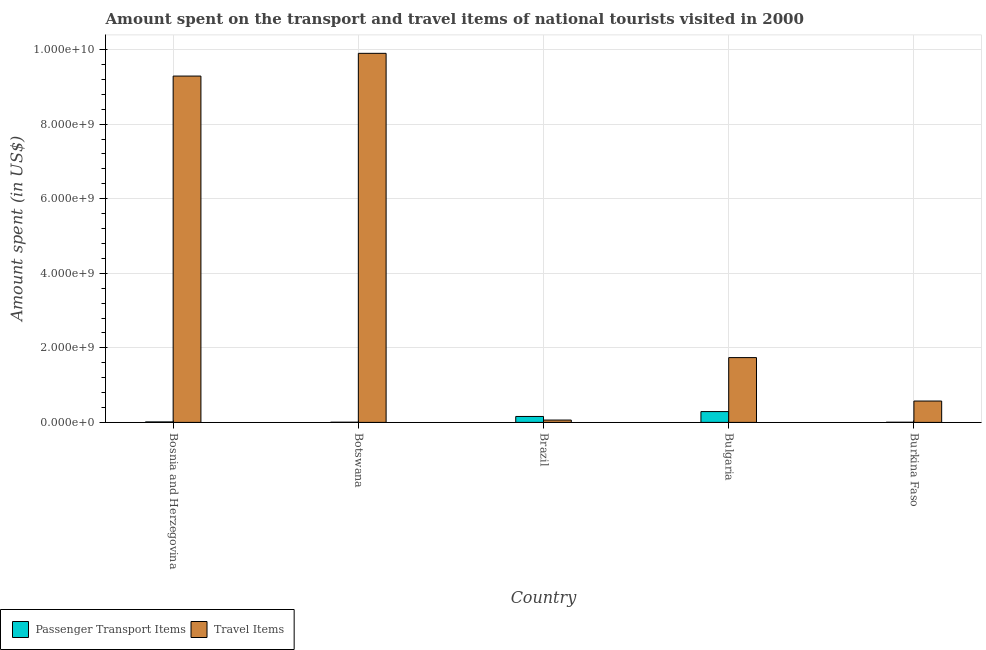How many groups of bars are there?
Offer a very short reply. 5. Are the number of bars on each tick of the X-axis equal?
Your answer should be compact. Yes. How many bars are there on the 3rd tick from the left?
Offer a terse response. 2. What is the label of the 5th group of bars from the left?
Offer a terse response. Burkina Faso. In how many cases, is the number of bars for a given country not equal to the number of legend labels?
Provide a short and direct response. 0. What is the amount spent on passenger transport items in Bosnia and Herzegovina?
Offer a terse response. 1.30e+07. Across all countries, what is the maximum amount spent on passenger transport items?
Keep it short and to the point. 2.90e+08. Across all countries, what is the minimum amount spent in travel items?
Your response must be concise. 6.30e+07. In which country was the amount spent on passenger transport items minimum?
Offer a terse response. Burkina Faso. What is the total amount spent on passenger transport items in the graph?
Your answer should be compact. 4.71e+08. What is the difference between the amount spent on passenger transport items in Botswana and that in Bulgaria?
Offer a very short reply. -2.85e+08. What is the difference between the amount spent in travel items in Burkina Faso and the amount spent on passenger transport items in Brazil?
Give a very brief answer. 4.14e+08. What is the average amount spent in travel items per country?
Your answer should be very brief. 4.31e+09. What is the difference between the amount spent on passenger transport items and amount spent in travel items in Bulgaria?
Give a very brief answer. -1.45e+09. What is the ratio of the amount spent on passenger transport items in Bulgaria to that in Burkina Faso?
Your answer should be compact. 72.5. Is the amount spent in travel items in Bosnia and Herzegovina less than that in Bulgaria?
Your answer should be very brief. No. What is the difference between the highest and the second highest amount spent in travel items?
Provide a short and direct response. 6.10e+08. What is the difference between the highest and the lowest amount spent on passenger transport items?
Offer a very short reply. 2.86e+08. In how many countries, is the amount spent on passenger transport items greater than the average amount spent on passenger transport items taken over all countries?
Your answer should be compact. 2. What does the 2nd bar from the left in Bulgaria represents?
Your answer should be compact. Travel Items. What does the 2nd bar from the right in Burkina Faso represents?
Your answer should be compact. Passenger Transport Items. How many bars are there?
Make the answer very short. 10. Are the values on the major ticks of Y-axis written in scientific E-notation?
Ensure brevity in your answer.  Yes. Does the graph contain any zero values?
Your answer should be compact. No. Where does the legend appear in the graph?
Give a very brief answer. Bottom left. How many legend labels are there?
Your response must be concise. 2. What is the title of the graph?
Ensure brevity in your answer.  Amount spent on the transport and travel items of national tourists visited in 2000. What is the label or title of the Y-axis?
Provide a succinct answer. Amount spent (in US$). What is the Amount spent (in US$) in Passenger Transport Items in Bosnia and Herzegovina?
Provide a succinct answer. 1.30e+07. What is the Amount spent (in US$) in Travel Items in Bosnia and Herzegovina?
Give a very brief answer. 9.29e+09. What is the Amount spent (in US$) of Travel Items in Botswana?
Keep it short and to the point. 9.90e+09. What is the Amount spent (in US$) of Passenger Transport Items in Brazil?
Give a very brief answer. 1.59e+08. What is the Amount spent (in US$) of Travel Items in Brazil?
Your answer should be compact. 6.30e+07. What is the Amount spent (in US$) of Passenger Transport Items in Bulgaria?
Make the answer very short. 2.90e+08. What is the Amount spent (in US$) of Travel Items in Bulgaria?
Give a very brief answer. 1.74e+09. What is the Amount spent (in US$) in Passenger Transport Items in Burkina Faso?
Give a very brief answer. 4.00e+06. What is the Amount spent (in US$) in Travel Items in Burkina Faso?
Keep it short and to the point. 5.73e+08. Across all countries, what is the maximum Amount spent (in US$) of Passenger Transport Items?
Your response must be concise. 2.90e+08. Across all countries, what is the maximum Amount spent (in US$) of Travel Items?
Provide a short and direct response. 9.90e+09. Across all countries, what is the minimum Amount spent (in US$) of Travel Items?
Your answer should be very brief. 6.30e+07. What is the total Amount spent (in US$) of Passenger Transport Items in the graph?
Keep it short and to the point. 4.71e+08. What is the total Amount spent (in US$) in Travel Items in the graph?
Provide a succinct answer. 2.16e+1. What is the difference between the Amount spent (in US$) in Passenger Transport Items in Bosnia and Herzegovina and that in Botswana?
Offer a very short reply. 8.00e+06. What is the difference between the Amount spent (in US$) in Travel Items in Bosnia and Herzegovina and that in Botswana?
Provide a short and direct response. -6.10e+08. What is the difference between the Amount spent (in US$) in Passenger Transport Items in Bosnia and Herzegovina and that in Brazil?
Make the answer very short. -1.46e+08. What is the difference between the Amount spent (in US$) of Travel Items in Bosnia and Herzegovina and that in Brazil?
Keep it short and to the point. 9.23e+09. What is the difference between the Amount spent (in US$) of Passenger Transport Items in Bosnia and Herzegovina and that in Bulgaria?
Your answer should be compact. -2.77e+08. What is the difference between the Amount spent (in US$) in Travel Items in Bosnia and Herzegovina and that in Bulgaria?
Give a very brief answer. 7.55e+09. What is the difference between the Amount spent (in US$) of Passenger Transport Items in Bosnia and Herzegovina and that in Burkina Faso?
Your response must be concise. 9.00e+06. What is the difference between the Amount spent (in US$) of Travel Items in Bosnia and Herzegovina and that in Burkina Faso?
Make the answer very short. 8.72e+09. What is the difference between the Amount spent (in US$) in Passenger Transport Items in Botswana and that in Brazil?
Give a very brief answer. -1.54e+08. What is the difference between the Amount spent (in US$) in Travel Items in Botswana and that in Brazil?
Give a very brief answer. 9.84e+09. What is the difference between the Amount spent (in US$) in Passenger Transport Items in Botswana and that in Bulgaria?
Your response must be concise. -2.85e+08. What is the difference between the Amount spent (in US$) in Travel Items in Botswana and that in Bulgaria?
Your response must be concise. 8.16e+09. What is the difference between the Amount spent (in US$) in Travel Items in Botswana and that in Burkina Faso?
Your answer should be very brief. 9.33e+09. What is the difference between the Amount spent (in US$) of Passenger Transport Items in Brazil and that in Bulgaria?
Offer a terse response. -1.31e+08. What is the difference between the Amount spent (in US$) in Travel Items in Brazil and that in Bulgaria?
Give a very brief answer. -1.68e+09. What is the difference between the Amount spent (in US$) of Passenger Transport Items in Brazil and that in Burkina Faso?
Ensure brevity in your answer.  1.55e+08. What is the difference between the Amount spent (in US$) of Travel Items in Brazil and that in Burkina Faso?
Your answer should be very brief. -5.10e+08. What is the difference between the Amount spent (in US$) of Passenger Transport Items in Bulgaria and that in Burkina Faso?
Offer a terse response. 2.86e+08. What is the difference between the Amount spent (in US$) of Travel Items in Bulgaria and that in Burkina Faso?
Offer a very short reply. 1.16e+09. What is the difference between the Amount spent (in US$) in Passenger Transport Items in Bosnia and Herzegovina and the Amount spent (in US$) in Travel Items in Botswana?
Give a very brief answer. -9.89e+09. What is the difference between the Amount spent (in US$) of Passenger Transport Items in Bosnia and Herzegovina and the Amount spent (in US$) of Travel Items in Brazil?
Offer a very short reply. -5.00e+07. What is the difference between the Amount spent (in US$) of Passenger Transport Items in Bosnia and Herzegovina and the Amount spent (in US$) of Travel Items in Bulgaria?
Provide a succinct answer. -1.72e+09. What is the difference between the Amount spent (in US$) in Passenger Transport Items in Bosnia and Herzegovina and the Amount spent (in US$) in Travel Items in Burkina Faso?
Your response must be concise. -5.60e+08. What is the difference between the Amount spent (in US$) of Passenger Transport Items in Botswana and the Amount spent (in US$) of Travel Items in Brazil?
Ensure brevity in your answer.  -5.80e+07. What is the difference between the Amount spent (in US$) of Passenger Transport Items in Botswana and the Amount spent (in US$) of Travel Items in Bulgaria?
Your answer should be very brief. -1.73e+09. What is the difference between the Amount spent (in US$) of Passenger Transport Items in Botswana and the Amount spent (in US$) of Travel Items in Burkina Faso?
Provide a short and direct response. -5.68e+08. What is the difference between the Amount spent (in US$) in Passenger Transport Items in Brazil and the Amount spent (in US$) in Travel Items in Bulgaria?
Your answer should be compact. -1.58e+09. What is the difference between the Amount spent (in US$) in Passenger Transport Items in Brazil and the Amount spent (in US$) in Travel Items in Burkina Faso?
Provide a short and direct response. -4.14e+08. What is the difference between the Amount spent (in US$) of Passenger Transport Items in Bulgaria and the Amount spent (in US$) of Travel Items in Burkina Faso?
Offer a very short reply. -2.83e+08. What is the average Amount spent (in US$) in Passenger Transport Items per country?
Give a very brief answer. 9.42e+07. What is the average Amount spent (in US$) of Travel Items per country?
Keep it short and to the point. 4.31e+09. What is the difference between the Amount spent (in US$) of Passenger Transport Items and Amount spent (in US$) of Travel Items in Bosnia and Herzegovina?
Offer a very short reply. -9.28e+09. What is the difference between the Amount spent (in US$) of Passenger Transport Items and Amount spent (in US$) of Travel Items in Botswana?
Your answer should be very brief. -9.89e+09. What is the difference between the Amount spent (in US$) in Passenger Transport Items and Amount spent (in US$) in Travel Items in Brazil?
Your response must be concise. 9.60e+07. What is the difference between the Amount spent (in US$) in Passenger Transport Items and Amount spent (in US$) in Travel Items in Bulgaria?
Make the answer very short. -1.45e+09. What is the difference between the Amount spent (in US$) in Passenger Transport Items and Amount spent (in US$) in Travel Items in Burkina Faso?
Keep it short and to the point. -5.69e+08. What is the ratio of the Amount spent (in US$) of Passenger Transport Items in Bosnia and Herzegovina to that in Botswana?
Provide a short and direct response. 2.6. What is the ratio of the Amount spent (in US$) of Travel Items in Bosnia and Herzegovina to that in Botswana?
Provide a succinct answer. 0.94. What is the ratio of the Amount spent (in US$) in Passenger Transport Items in Bosnia and Herzegovina to that in Brazil?
Offer a terse response. 0.08. What is the ratio of the Amount spent (in US$) in Travel Items in Bosnia and Herzegovina to that in Brazil?
Provide a succinct answer. 147.44. What is the ratio of the Amount spent (in US$) in Passenger Transport Items in Bosnia and Herzegovina to that in Bulgaria?
Offer a very short reply. 0.04. What is the ratio of the Amount spent (in US$) in Travel Items in Bosnia and Herzegovina to that in Bulgaria?
Make the answer very short. 5.34. What is the ratio of the Amount spent (in US$) of Passenger Transport Items in Bosnia and Herzegovina to that in Burkina Faso?
Your answer should be compact. 3.25. What is the ratio of the Amount spent (in US$) in Travel Items in Bosnia and Herzegovina to that in Burkina Faso?
Ensure brevity in your answer.  16.21. What is the ratio of the Amount spent (in US$) of Passenger Transport Items in Botswana to that in Brazil?
Offer a very short reply. 0.03. What is the ratio of the Amount spent (in US$) in Travel Items in Botswana to that in Brazil?
Your response must be concise. 157.13. What is the ratio of the Amount spent (in US$) of Passenger Transport Items in Botswana to that in Bulgaria?
Your response must be concise. 0.02. What is the ratio of the Amount spent (in US$) of Travel Items in Botswana to that in Bulgaria?
Keep it short and to the point. 5.7. What is the ratio of the Amount spent (in US$) in Travel Items in Botswana to that in Burkina Faso?
Ensure brevity in your answer.  17.28. What is the ratio of the Amount spent (in US$) of Passenger Transport Items in Brazil to that in Bulgaria?
Make the answer very short. 0.55. What is the ratio of the Amount spent (in US$) in Travel Items in Brazil to that in Bulgaria?
Your response must be concise. 0.04. What is the ratio of the Amount spent (in US$) in Passenger Transport Items in Brazil to that in Burkina Faso?
Your answer should be compact. 39.75. What is the ratio of the Amount spent (in US$) in Travel Items in Brazil to that in Burkina Faso?
Make the answer very short. 0.11. What is the ratio of the Amount spent (in US$) in Passenger Transport Items in Bulgaria to that in Burkina Faso?
Your answer should be compact. 72.5. What is the ratio of the Amount spent (in US$) of Travel Items in Bulgaria to that in Burkina Faso?
Offer a terse response. 3.03. What is the difference between the highest and the second highest Amount spent (in US$) of Passenger Transport Items?
Provide a succinct answer. 1.31e+08. What is the difference between the highest and the second highest Amount spent (in US$) in Travel Items?
Offer a very short reply. 6.10e+08. What is the difference between the highest and the lowest Amount spent (in US$) of Passenger Transport Items?
Offer a very short reply. 2.86e+08. What is the difference between the highest and the lowest Amount spent (in US$) of Travel Items?
Provide a succinct answer. 9.84e+09. 